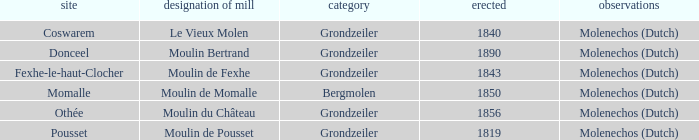What is the Name of the Grondzeiler Mill? Le Vieux Molen, Moulin Bertrand, Moulin de Fexhe, Moulin du Château, Moulin de Pousset. Could you parse the entire table as a dict? {'header': ['site', 'designation of mill', 'category', 'erected', 'observations'], 'rows': [['Coswarem', 'Le Vieux Molen', 'Grondzeiler', '1840', 'Molenechos (Dutch)'], ['Donceel', 'Moulin Bertrand', 'Grondzeiler', '1890', 'Molenechos (Dutch)'], ['Fexhe-le-haut-Clocher', 'Moulin de Fexhe', 'Grondzeiler', '1843', 'Molenechos (Dutch)'], ['Momalle', 'Moulin de Momalle', 'Bergmolen', '1850', 'Molenechos (Dutch)'], ['Othée', 'Moulin du Château', 'Grondzeiler', '1856', 'Molenechos (Dutch)'], ['Pousset', 'Moulin de Pousset', 'Grondzeiler', '1819', 'Molenechos (Dutch)']]} 